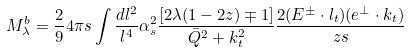Convert formula to latex. <formula><loc_0><loc_0><loc_500><loc_500>M ^ { b } _ { \lambda } = \frac { 2 } { 9 } 4 \pi s \int \frac { d l ^ { 2 } } { l ^ { 4 } } \alpha _ { s } ^ { 2 } \frac { [ 2 \lambda ( 1 - 2 z ) \mp 1 ] } { \bar { Q } ^ { 2 } + k ^ { 2 } _ { t } } \frac { 2 ( E ^ { \pm } \cdot l _ { t } ) ( e ^ { \perp } \cdot k _ { t } ) } { z s }</formula> 